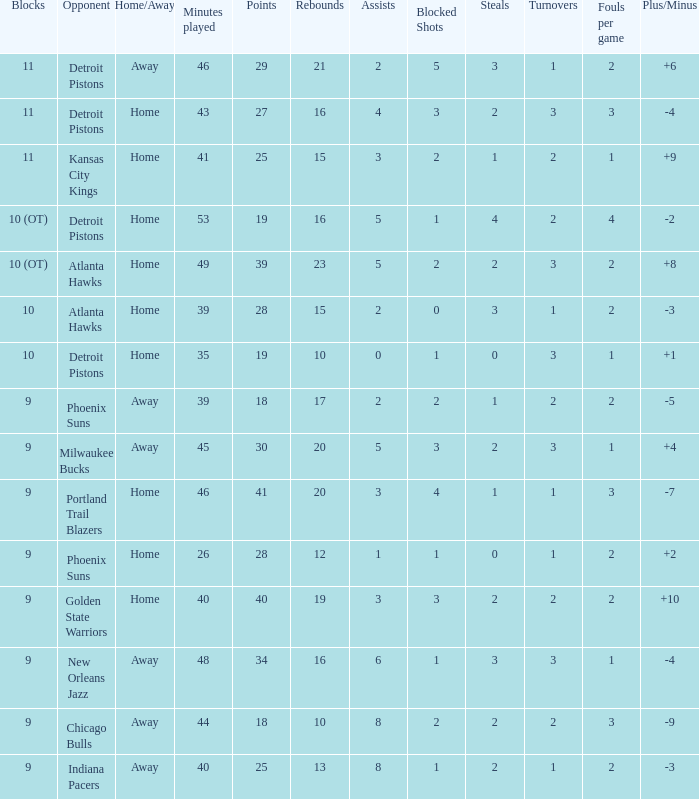How many minutes were played when there were 18 points and the opponent was Chicago Bulls? 1.0. 